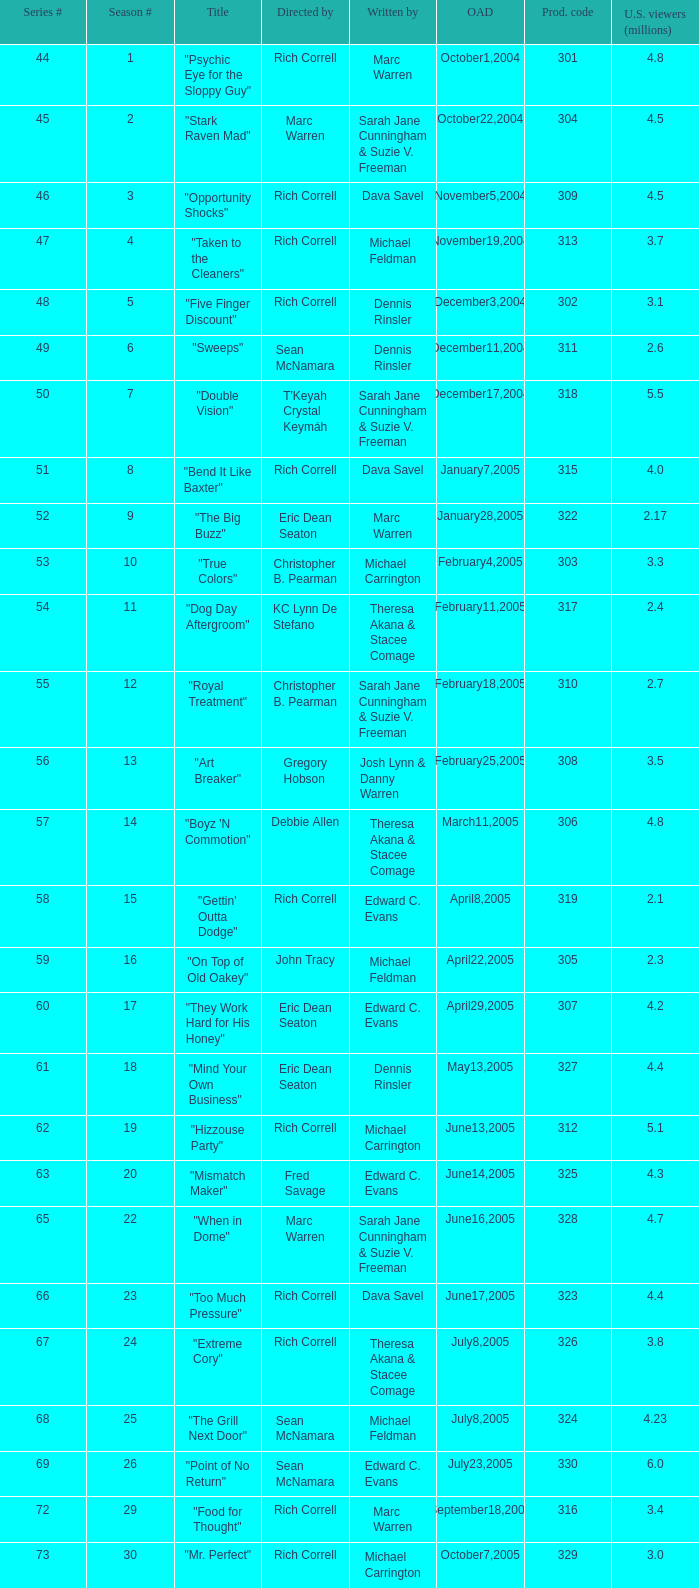Which episode number of the season had the title "vision impossible"? 34.0. 